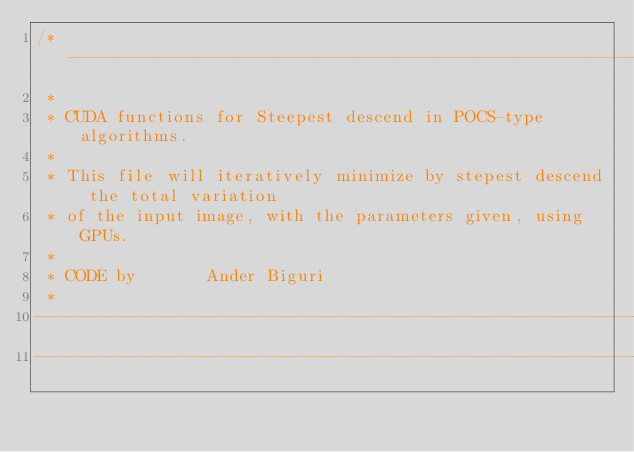<code> <loc_0><loc_0><loc_500><loc_500><_Cuda_>/*-------------------------------------------------------------------------
 *
 * CUDA functions for Steepest descend in POCS-type algorithms.
 *
 * This file will iteratively minimize by stepest descend the total variation 
 * of the input image, with the parameters given, using GPUs.
 *
 * CODE by       Ander Biguri
 *
---------------------------------------------------------------------------
---------------------------------------------------------------------------</code> 